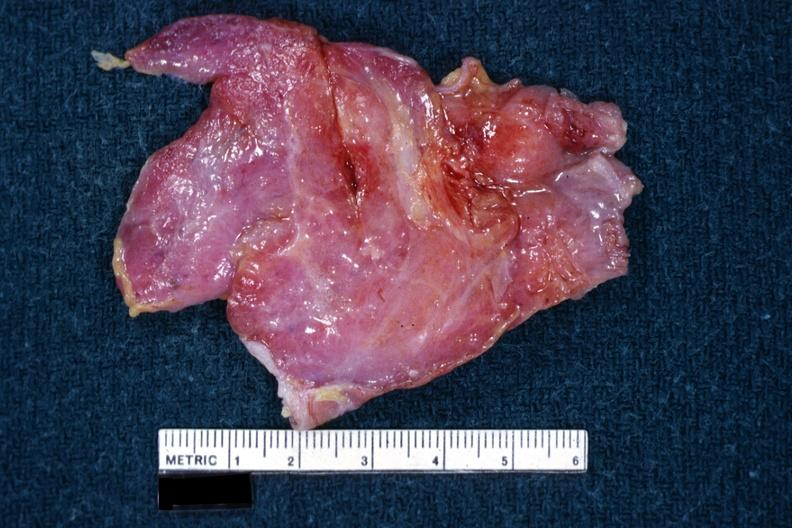s thymoma present?
Answer the question using a single word or phrase. Yes 